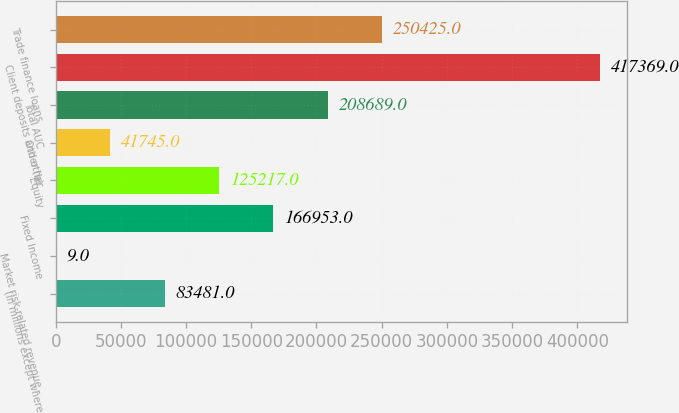<chart> <loc_0><loc_0><loc_500><loc_500><bar_chart><fcel>(in millions except where<fcel>Market risk-related revenue -<fcel>Fixed Income<fcel>Equity<fcel>Other (b)<fcel>Total AUC<fcel>Client deposits and other<fcel>Trade finance loans<nl><fcel>83481<fcel>9<fcel>166953<fcel>125217<fcel>41745<fcel>208689<fcel>417369<fcel>250425<nl></chart> 